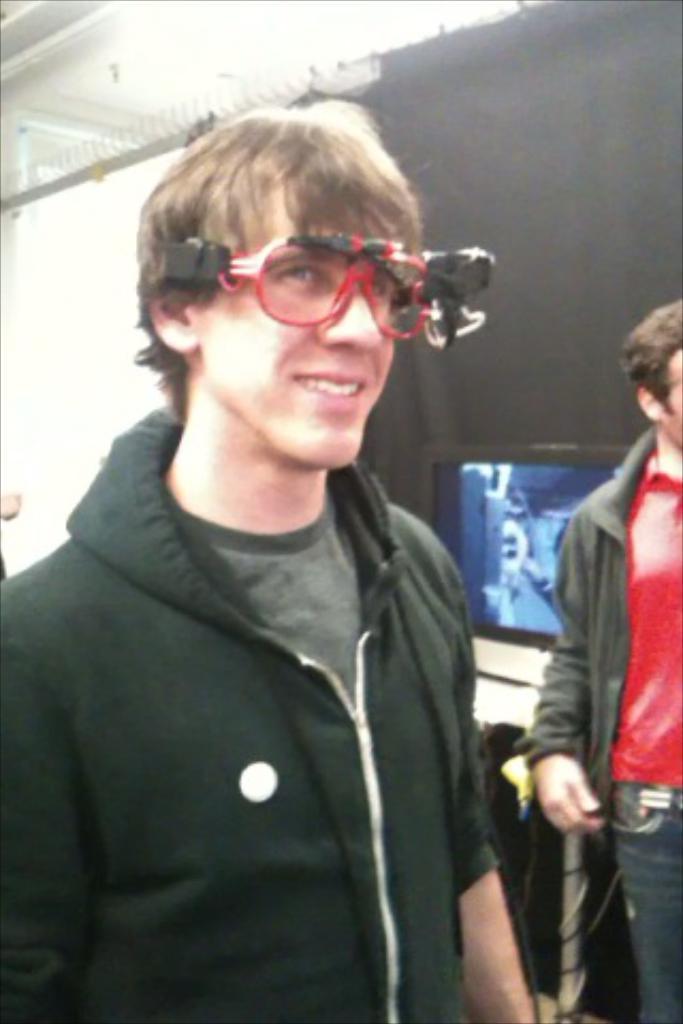Please provide a concise description of this image. In the image we can see there are two men standing, wearing clothes and the left side man is smiling and wearing spectacles. Here we can see screen and black curtains. 